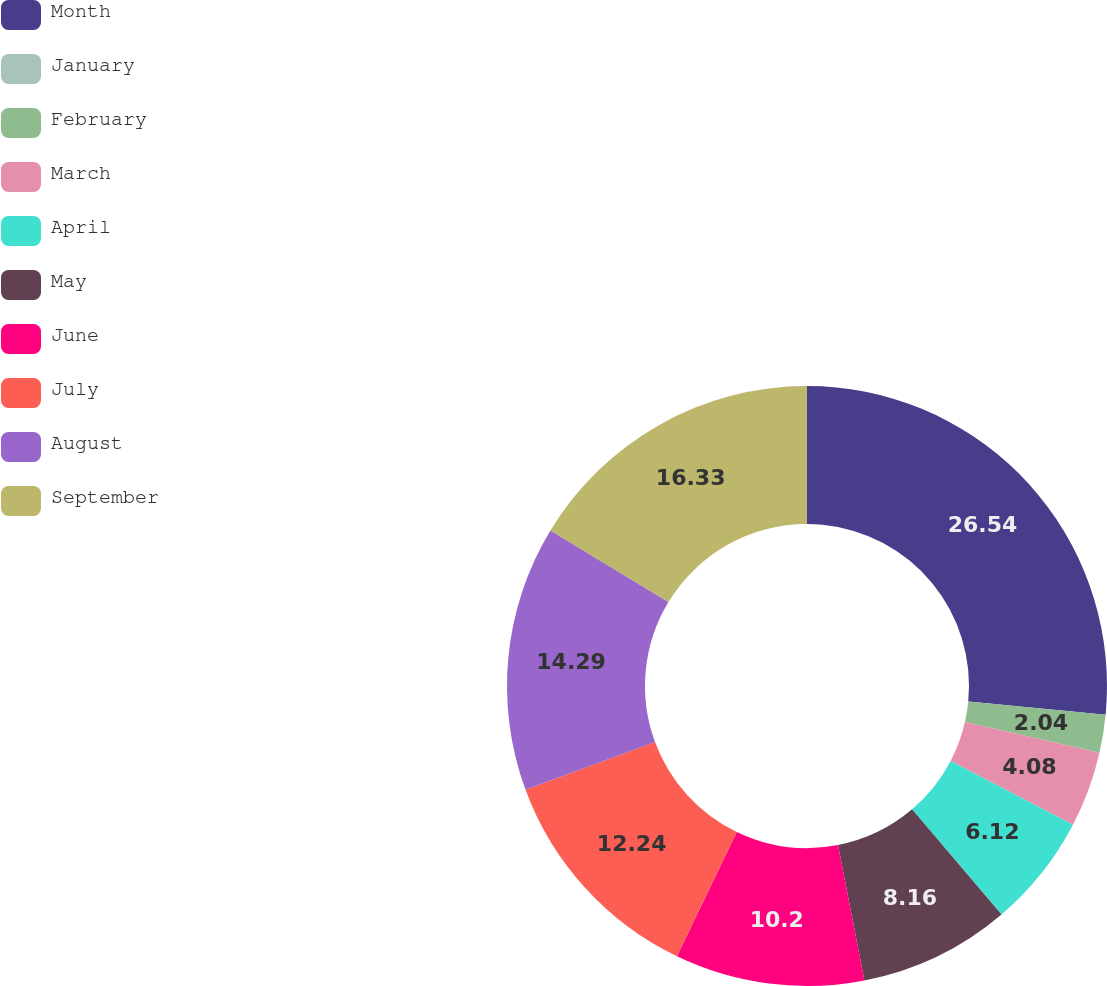Convert chart. <chart><loc_0><loc_0><loc_500><loc_500><pie_chart><fcel>Month<fcel>January<fcel>February<fcel>March<fcel>April<fcel>May<fcel>June<fcel>July<fcel>August<fcel>September<nl><fcel>26.53%<fcel>0.0%<fcel>2.04%<fcel>4.08%<fcel>6.12%<fcel>8.16%<fcel>10.2%<fcel>12.24%<fcel>14.29%<fcel>16.33%<nl></chart> 